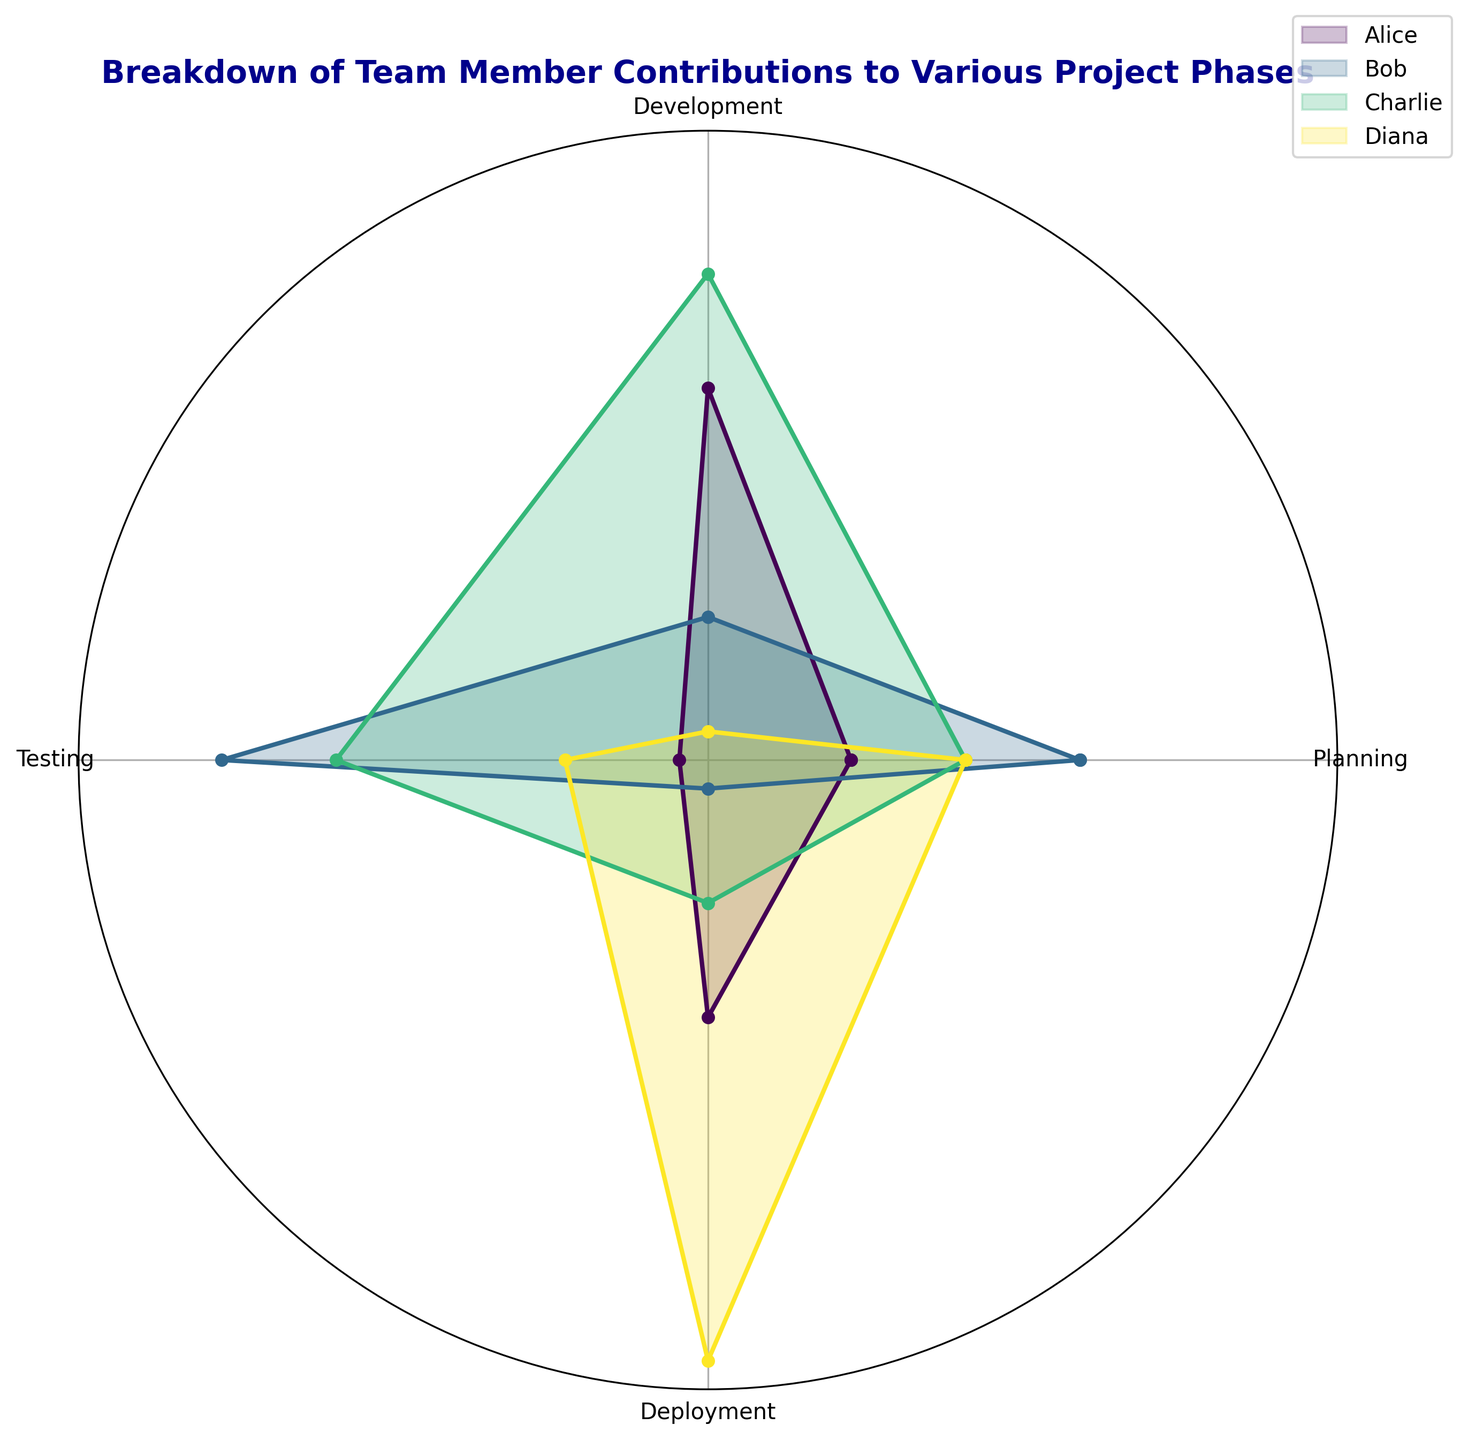What phase had the highest contribution by Diana? By examining the plot, you can see the area and angle corresponding to Diana's contributions. The Deployment phase shows the largest section for Diana, indicating the highest contribution.
Answer: Deployment Who contributed the most overall in the Development phase? Compare the heights of the wedges in the Development phase for all members. Charlie's wedge is tallest, indicating he contributed the most.
Answer: Charlie In which phase did Alice and Bob have equal contributions? Look at the segments for Alice and Bob in each phase. The Planning phase shows equal contributions as their wedges align at the same height.
Answer: Planning What is the combined contribution of Alice in the Planning and Deployment phases? Add Alice's contributions from the Planning phase (20) and Deployment phase (25). The sum is 20 + 25.
Answer: 45 Which member had the least contribution in the Testing phase? Compare the wedges for all members in the Testing phase. Alice’s wedge is shortest, indicating the least contribution.
Answer: Alice What phase shows an equal contribution from Bob and Charlie? Look at the segments for Bob and Charlie in each phase. The Deployment phase shows their wedges aligning at the same height.
Answer: Deployment Between Diana and Alice, who contributed more to the Testing phase? Compare the wedges for Diana and Alice in the Testing phase. Diana’s wedge is taller, indicating she contributed more.
Answer: Diana What is Charlie's average contribution across all phases? Add Charlie's contributions from all phases: Planning (25), Development (35), Testing (30), and Deployment (20). Divide the sum by the number of phases (4). The average is (25 + 35 + 30 + 20) / 4.
Answer: 27.5 In which phase is the difference between Charlie and Bob's contribution the greatest? Calculate the differences for each phase: Planning (25-30=-5), Development (35-20=15), Testing (30-35=-5), Deployment (20-15=5). The greatest difference is in the Development phase.
Answer: Development 